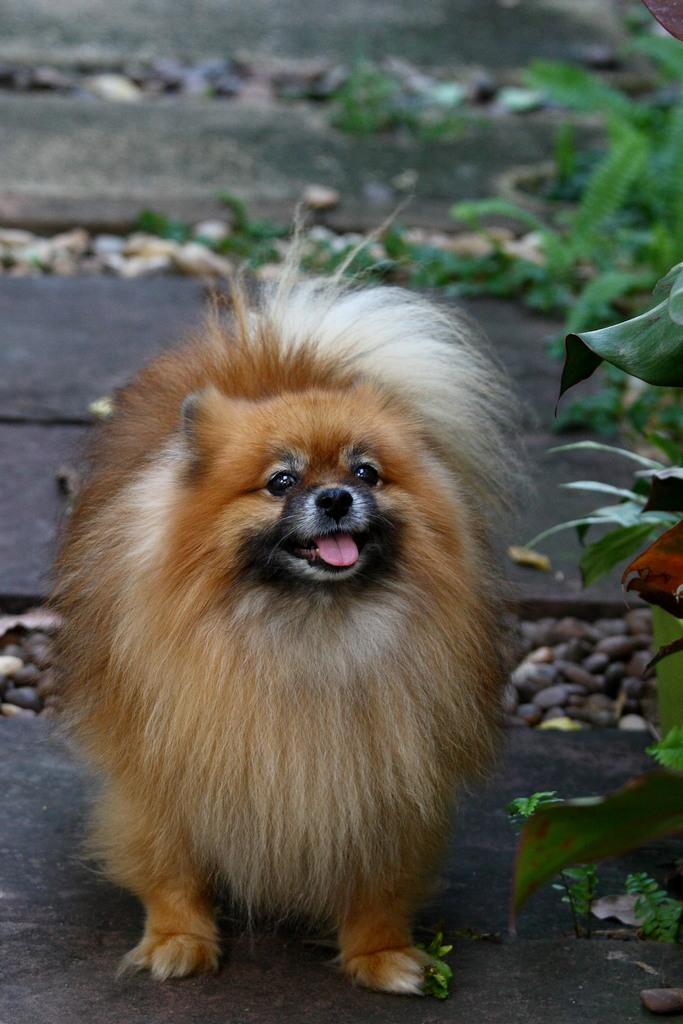What type of animal is present in the image? There is a dog in the image. What other elements can be seen in the image besides the dog? There are plants and leaves on the ground in the image. What type of furniture is depicted in the image? There is no furniture present in the image. What kind of pain is the dog experiencing in the image? There is no indication of pain or any emotional state for the dog in the image. 